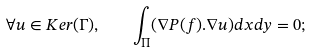<formula> <loc_0><loc_0><loc_500><loc_500>\forall u \in K e r ( \Gamma ) , \quad \int _ { \Pi } ( \nabla P ( f ) . \nabla u ) d x d y = 0 ;</formula> 